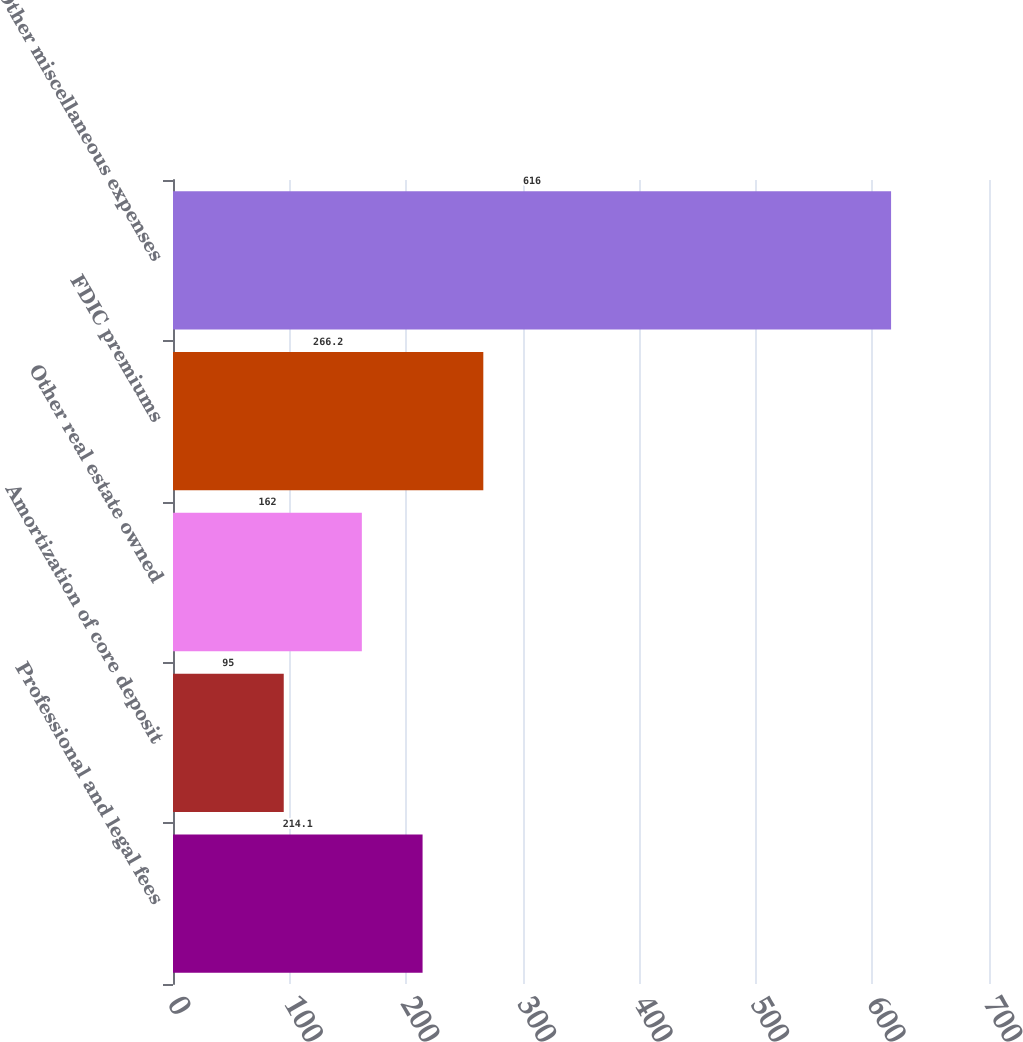<chart> <loc_0><loc_0><loc_500><loc_500><bar_chart><fcel>Professional and legal fees<fcel>Amortization of core deposit<fcel>Other real estate owned<fcel>FDIC premiums<fcel>Other miscellaneous expenses<nl><fcel>214.1<fcel>95<fcel>162<fcel>266.2<fcel>616<nl></chart> 